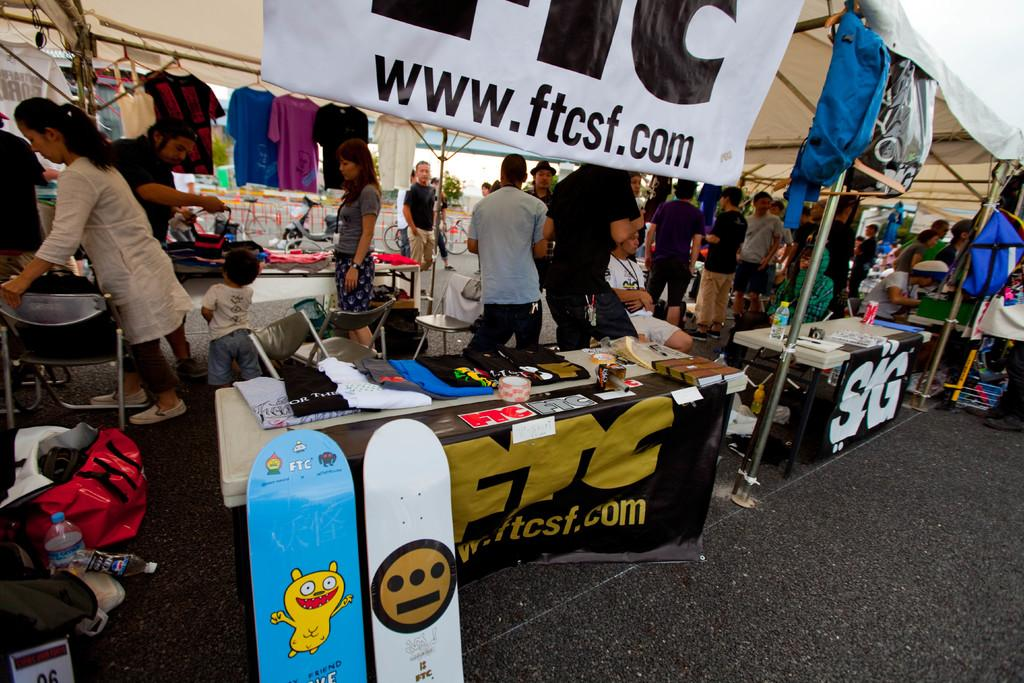What type of structures are in the image? There are stalls in the image. What items can be seen related to sports or recreation? Skateboards are present in the image. What objects might be used for hydration? Water bottles are visible in the image. What type of furniture is in the image? Tables and chairs are present in the image. What items might be used for carrying belongings? Bags are present in the image. What items might be used for displaying or reading? Books are visible in the image. What type of clothing storage is in the image? Clothes are hung on hangers in the image. What type of signage is in the image? There is a banner in the image. What type of temporary shelter is in the image? A tent is visible in the image. What type of pest can be seen crawling on the skateboards in the image? There are no pests visible on the skateboards in the image. How does the edge of the banner affect the overall appearance of the image? The edge of the banner is not mentioned in the provided facts, so it cannot be determined how it affects the overall appearance of the image. 